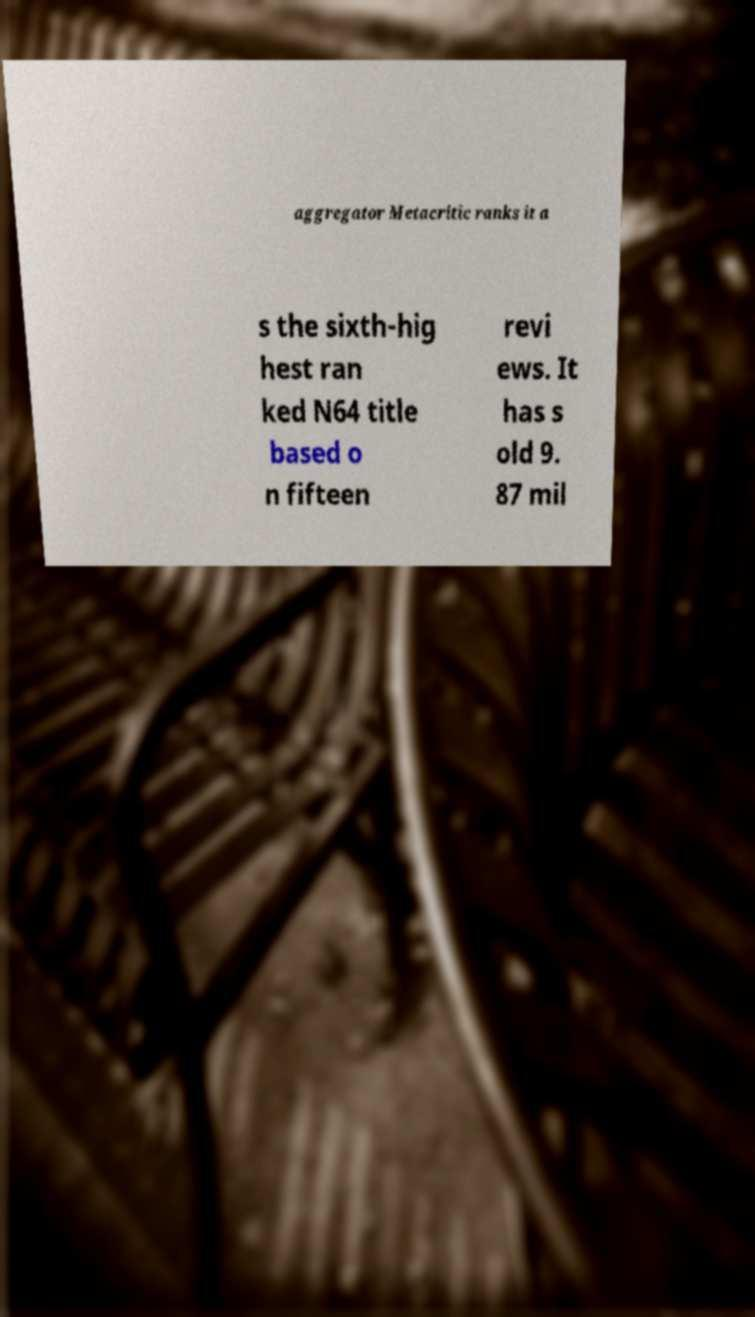Please identify and transcribe the text found in this image. aggregator Metacritic ranks it a s the sixth-hig hest ran ked N64 title based o n fifteen revi ews. It has s old 9. 87 mil 